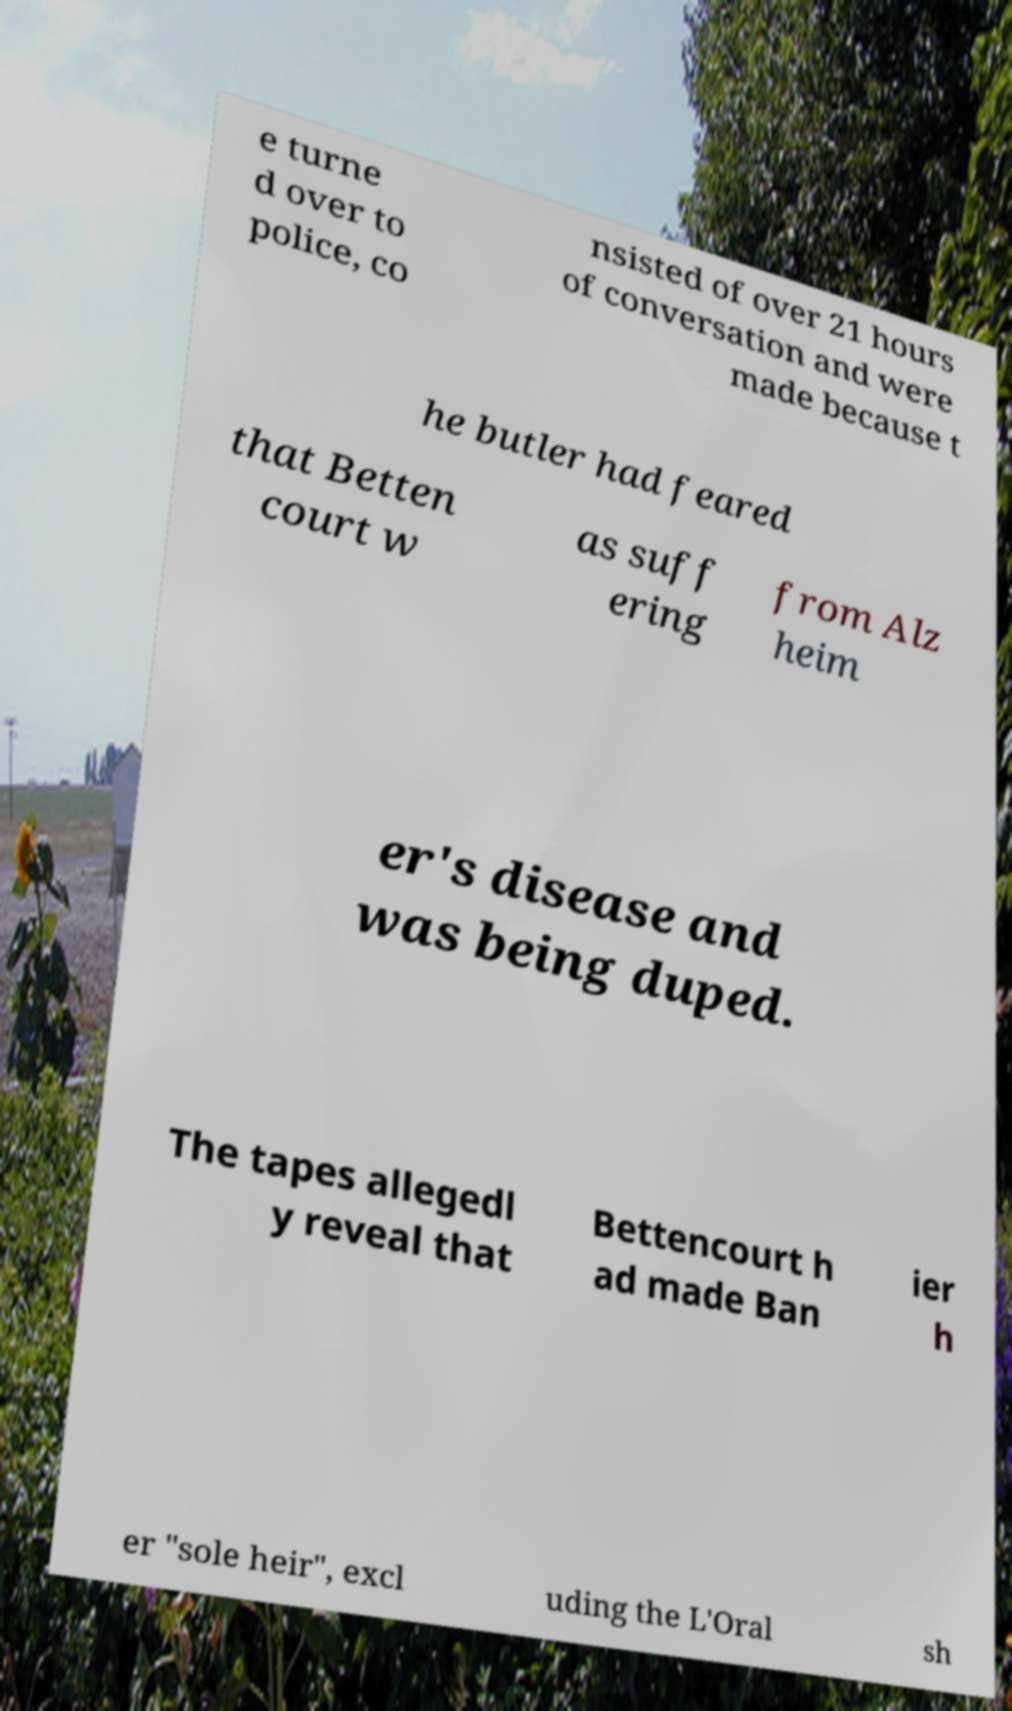Please identify and transcribe the text found in this image. e turne d over to police, co nsisted of over 21 hours of conversation and were made because t he butler had feared that Betten court w as suff ering from Alz heim er's disease and was being duped. The tapes allegedl y reveal that Bettencourt h ad made Ban ier h er "sole heir", excl uding the L'Oral sh 